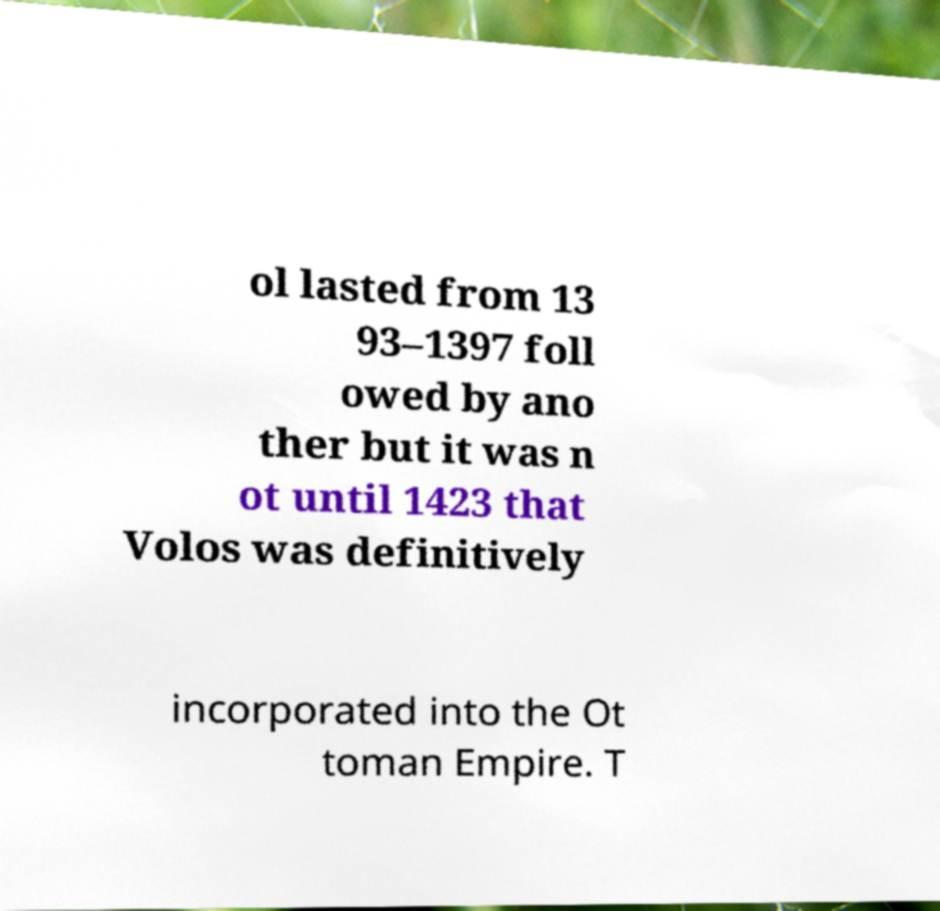I need the written content from this picture converted into text. Can you do that? ol lasted from 13 93–1397 foll owed by ano ther but it was n ot until 1423 that Volos was definitively incorporated into the Ot toman Empire. T 